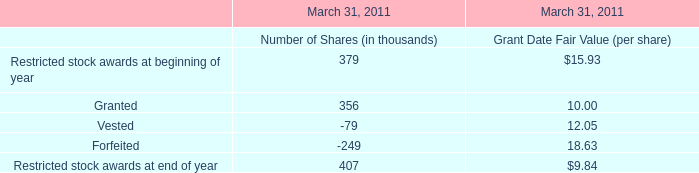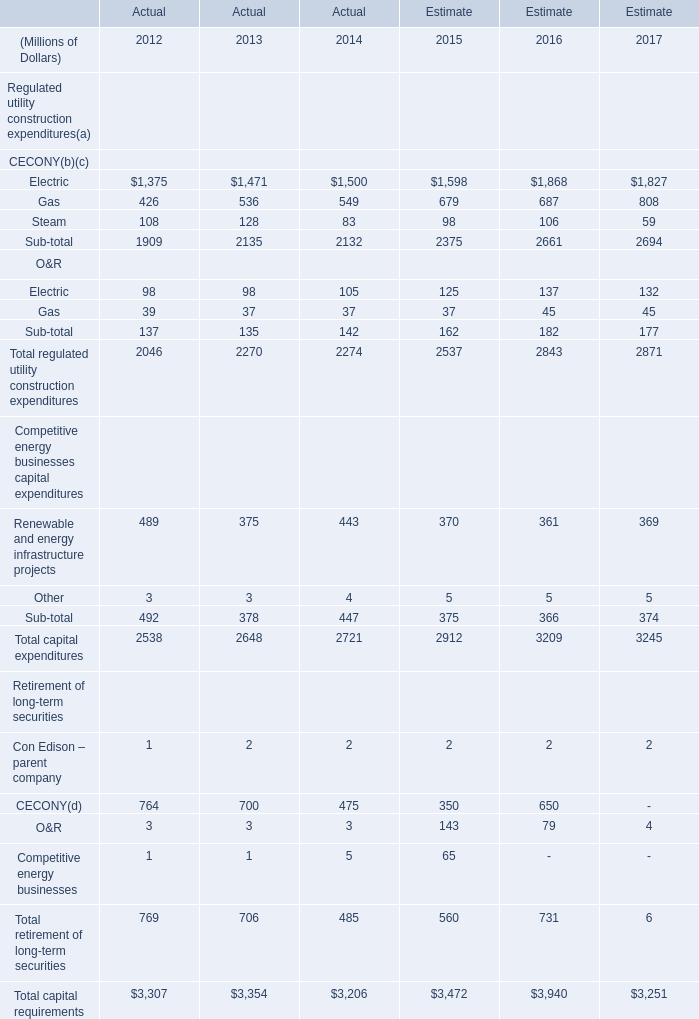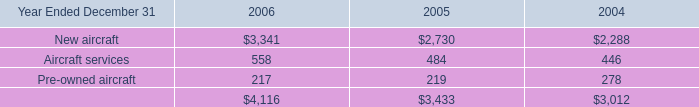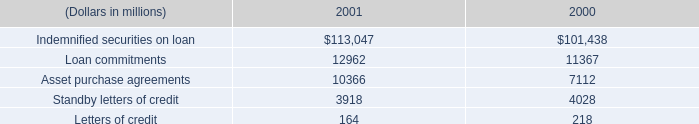What is the growing rate of Gas in the year with the most Electric? 
Computations: ((687 - 679) / 679)
Answer: 0.01178. 